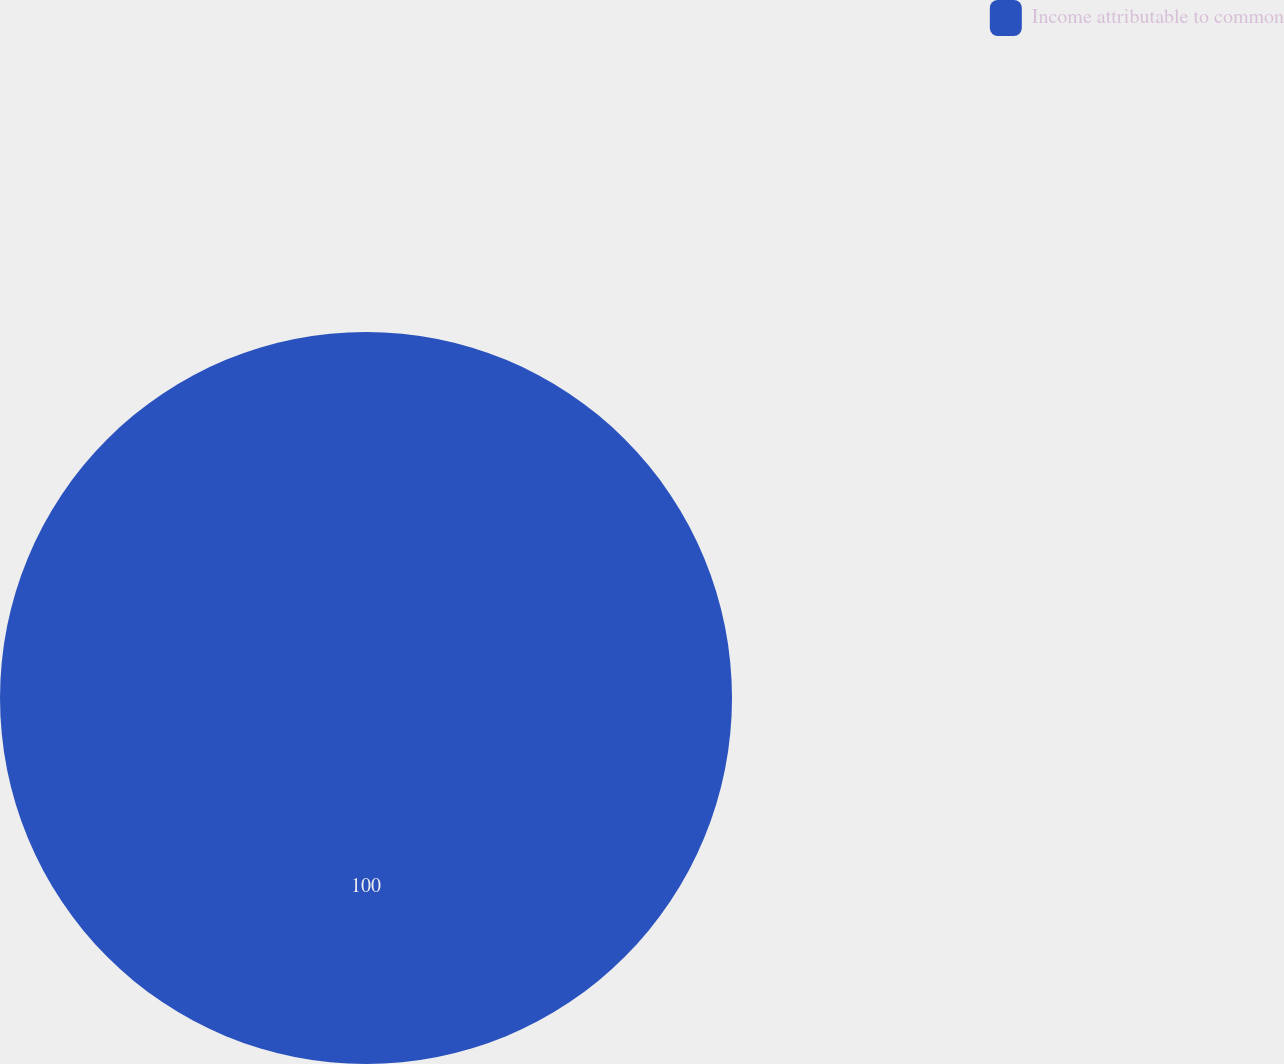<chart> <loc_0><loc_0><loc_500><loc_500><pie_chart><fcel>Income attributable to common<nl><fcel>100.0%<nl></chart> 